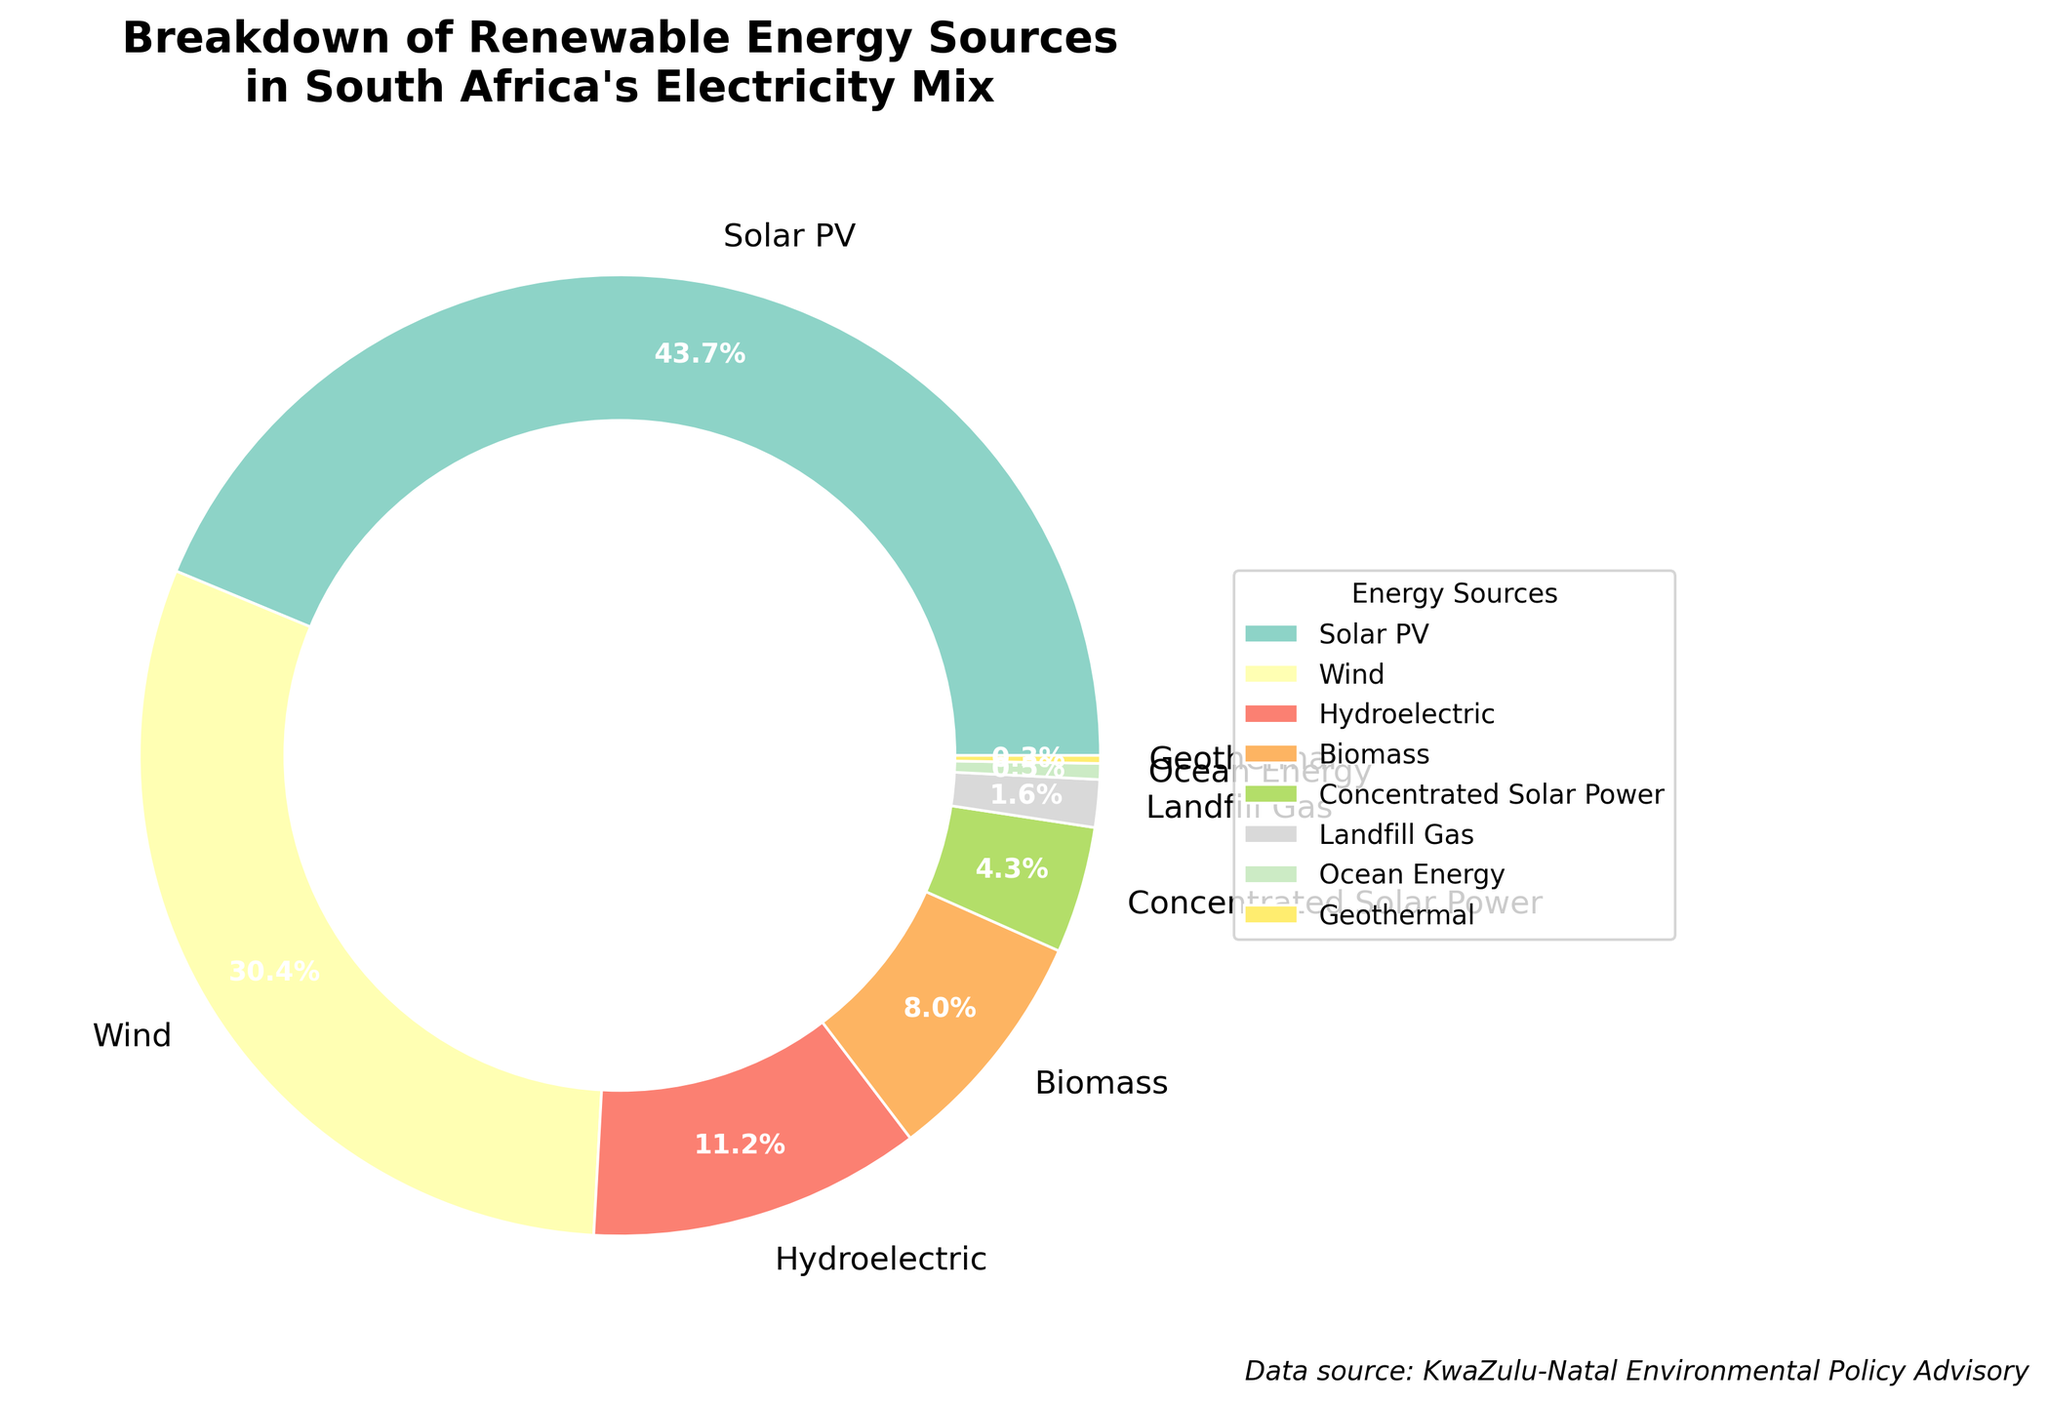What is the most dominant renewable energy source in South Africa's electricity mix according to the figure? The figure shows eight different renewable energy sources. By examining the wedges of the pie chart, the widest slice corresponds to "Solar PV" with a significant percentage.
Answer: Solar PV Which renewable energy source has the smallest share in South Africa's electricity mix? From the pie chart, the narrowest wedge represents "Geothermal," indicating that it has the smallest share.
Answer: Geothermal How much bigger is the share of Wind compared to Biomass in percentage terms? To determine the difference, look at the percentages for Wind and Biomass. Wind has 5.7%, and Biomass has 1.5%. Subtracting these gives: 5.7% - 1.5% = 4.2%.
Answer: 4.2% What's the combined percentage of Hydroelectric and Concentrated Solar Power? The percentages for Hydroelectric and Concentrated Solar Power are 2.1% and 0.8%, respectively. Adding these together: 2.1% + 0.8% = 2.9%.
Answer: 2.9% Which energy source constitutes a fraction of the combined share of "Solar PV" and "Wind"? "Solar PV" has 8.2% and "Wind" has 5.7%. Their combined share is 8.2% + 5.7% = 13.9%. "Biomass" constitutes 1.5%, while 1.5% is a fraction of 13.9%.
Answer: Biomass Among the visual attributes of the chart, what distinctive feature can be noticed about the slice representing Ocean Energy? The pie chart uses distinct colors for each slice, and Ocean Energy is depicted with an extremely thin slice. This visual representation emphasizes its minor proportion of the total.
Answer: Extremely thin slice If you combine the shares of all sources except Solar PV, do they exceed 10%? Adding the shares of Wind (5.7%), Hydroelectric (2.1%), Biomass (1.5%), Concentrated Solar Power (0.8%), Landfill Gas (0.3%), Ocean Energy (0.1%), and Geothermal (0.05%) gives: 5.7 + 2.1 + 1.5 + 0.8 + 0.3 + 0.1 + 0.05 = 10.55%, which exceeds 10%.
Answer: Yes What is the percentage difference between the highest and lowest renewable energy sources? The highest share is Solar PV at 8.2%, and the lowest is Geothermal at 0.05%. The difference is: 8.2% - 0.05% = 8.15%.
Answer: 8.15% If you were to discuss the proportion of these energy sources with a focus on those under 1%, how many sources would you include? The renewable energy sources under 1% are Concentrated Solar Power (0.8%), Landfill Gas (0.3%), Ocean Energy (0.1%), and Geothermal (0.05%). This totals to four sources.
Answer: Four Which energy sources combined just fall a bit short of half the share of Solar PV? Concentrated Solar Power (0.8%) and Landfill Gas (0.3%) combined give 0.8% + 0.3% = 1.1%, which is slightly more than half of 8.2% (which would be 4.1%). Biomass (1.5%) is closer but is not half. Hence, combining these two substantial portions points to "Biomass" and "Concentrated Solar Power".
Answer: Concentrated Solar Power and Landfill Gas 